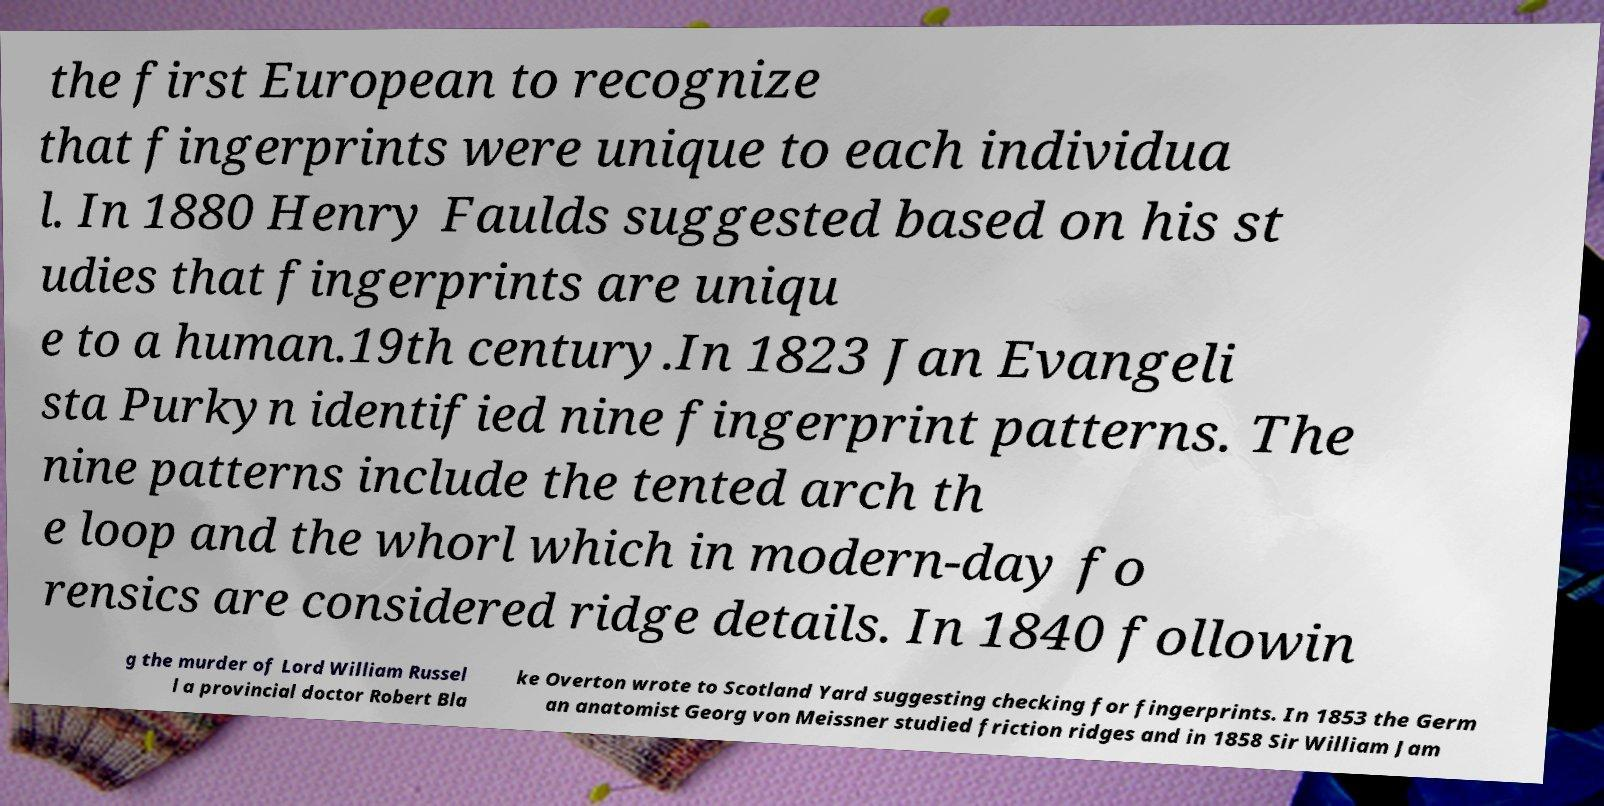Can you accurately transcribe the text from the provided image for me? the first European to recognize that fingerprints were unique to each individua l. In 1880 Henry Faulds suggested based on his st udies that fingerprints are uniqu e to a human.19th century.In 1823 Jan Evangeli sta Purkyn identified nine fingerprint patterns. The nine patterns include the tented arch th e loop and the whorl which in modern-day fo rensics are considered ridge details. In 1840 followin g the murder of Lord William Russel l a provincial doctor Robert Bla ke Overton wrote to Scotland Yard suggesting checking for fingerprints. In 1853 the Germ an anatomist Georg von Meissner studied friction ridges and in 1858 Sir William Jam 